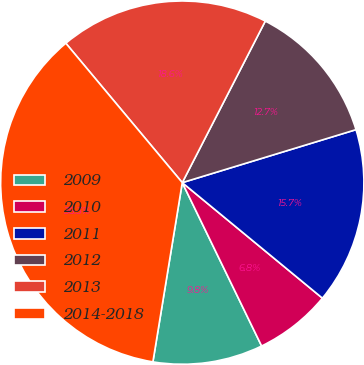<chart> <loc_0><loc_0><loc_500><loc_500><pie_chart><fcel>2009<fcel>2010<fcel>2011<fcel>2012<fcel>2013<fcel>2014-2018<nl><fcel>9.78%<fcel>6.83%<fcel>15.68%<fcel>12.73%<fcel>18.63%<fcel>36.33%<nl></chart> 